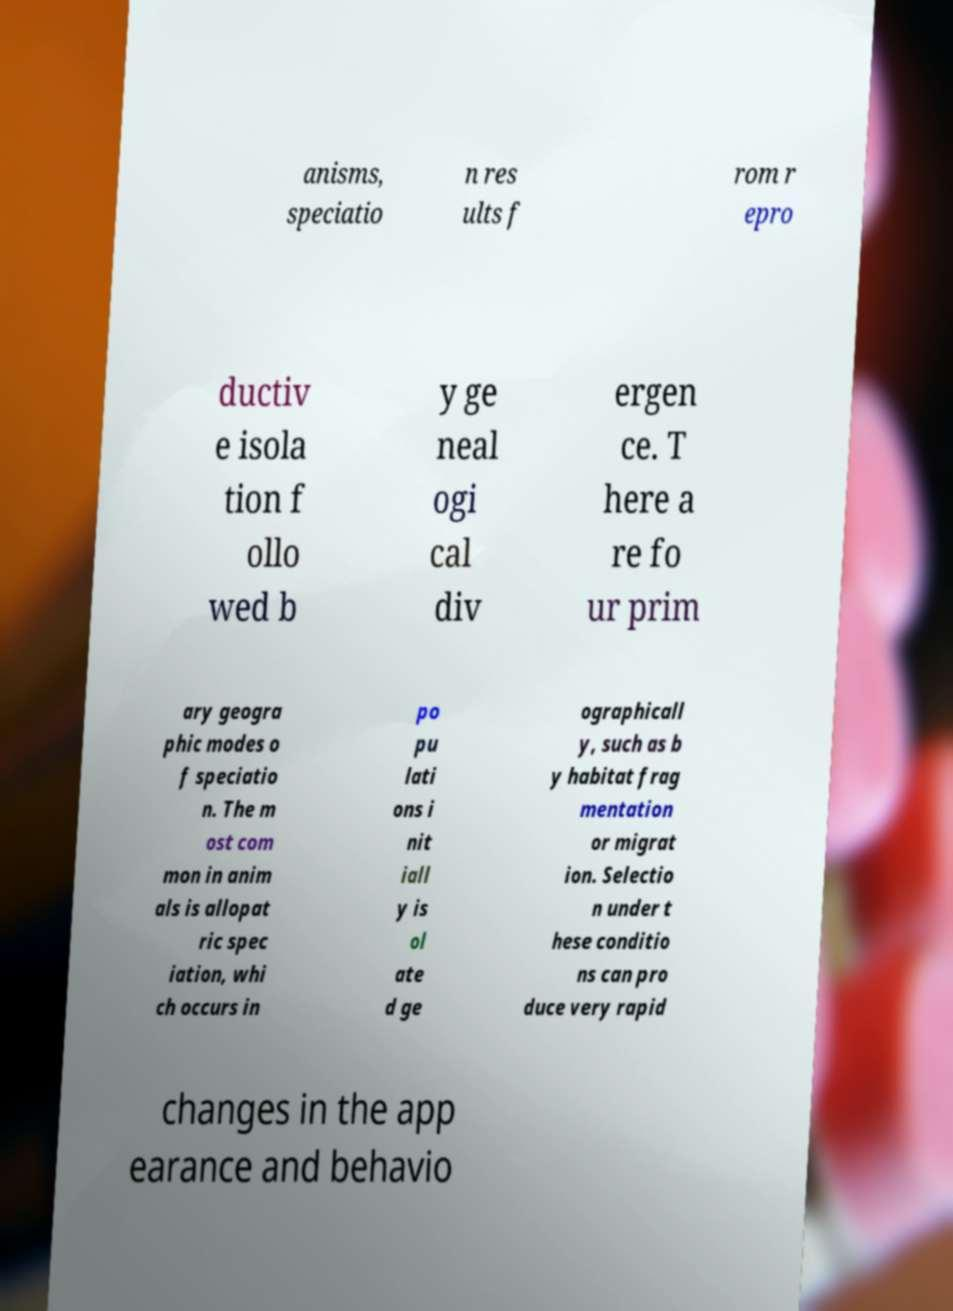Please read and relay the text visible in this image. What does it say? anisms, speciatio n res ults f rom r epro ductiv e isola tion f ollo wed b y ge neal ogi cal div ergen ce. T here a re fo ur prim ary geogra phic modes o f speciatio n. The m ost com mon in anim als is allopat ric spec iation, whi ch occurs in po pu lati ons i nit iall y is ol ate d ge ographicall y, such as b y habitat frag mentation or migrat ion. Selectio n under t hese conditio ns can pro duce very rapid changes in the app earance and behavio 